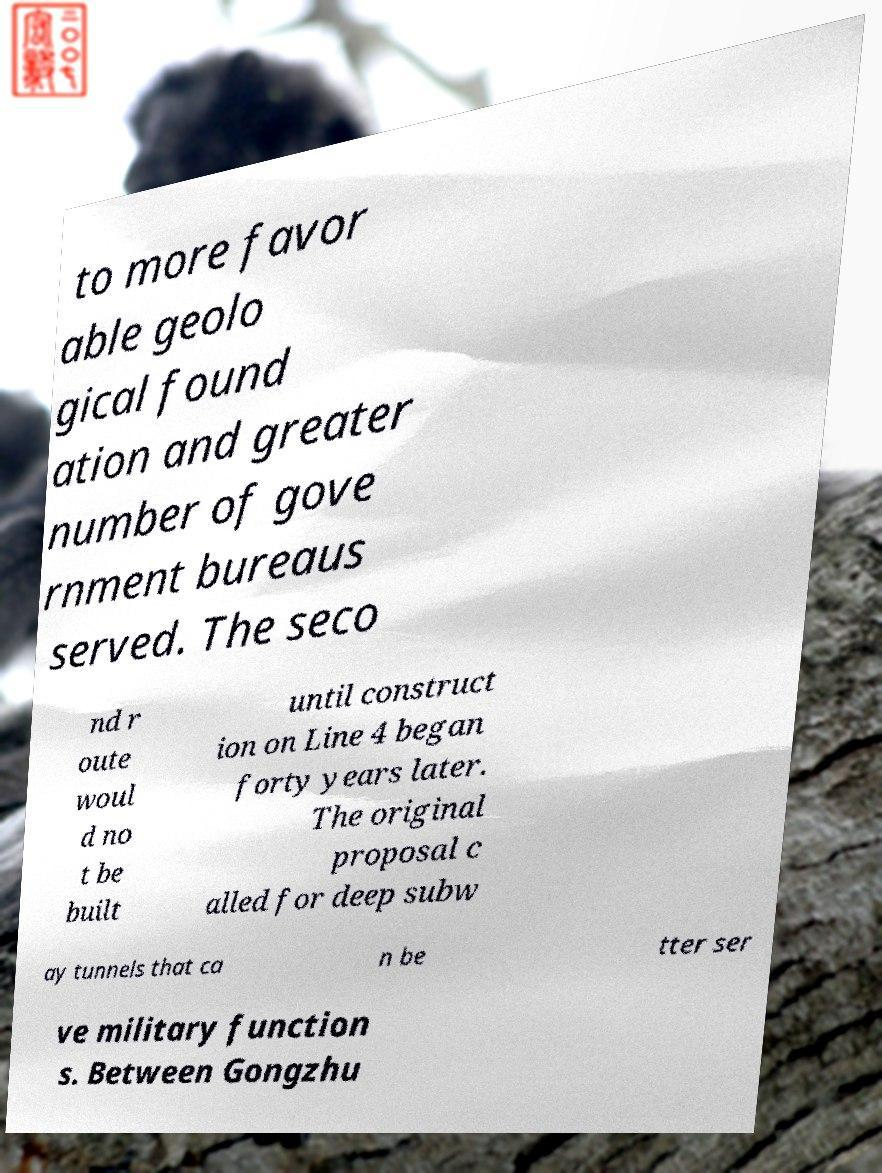There's text embedded in this image that I need extracted. Can you transcribe it verbatim? to more favor able geolo gical found ation and greater number of gove rnment bureaus served. The seco nd r oute woul d no t be built until construct ion on Line 4 began forty years later. The original proposal c alled for deep subw ay tunnels that ca n be tter ser ve military function s. Between Gongzhu 